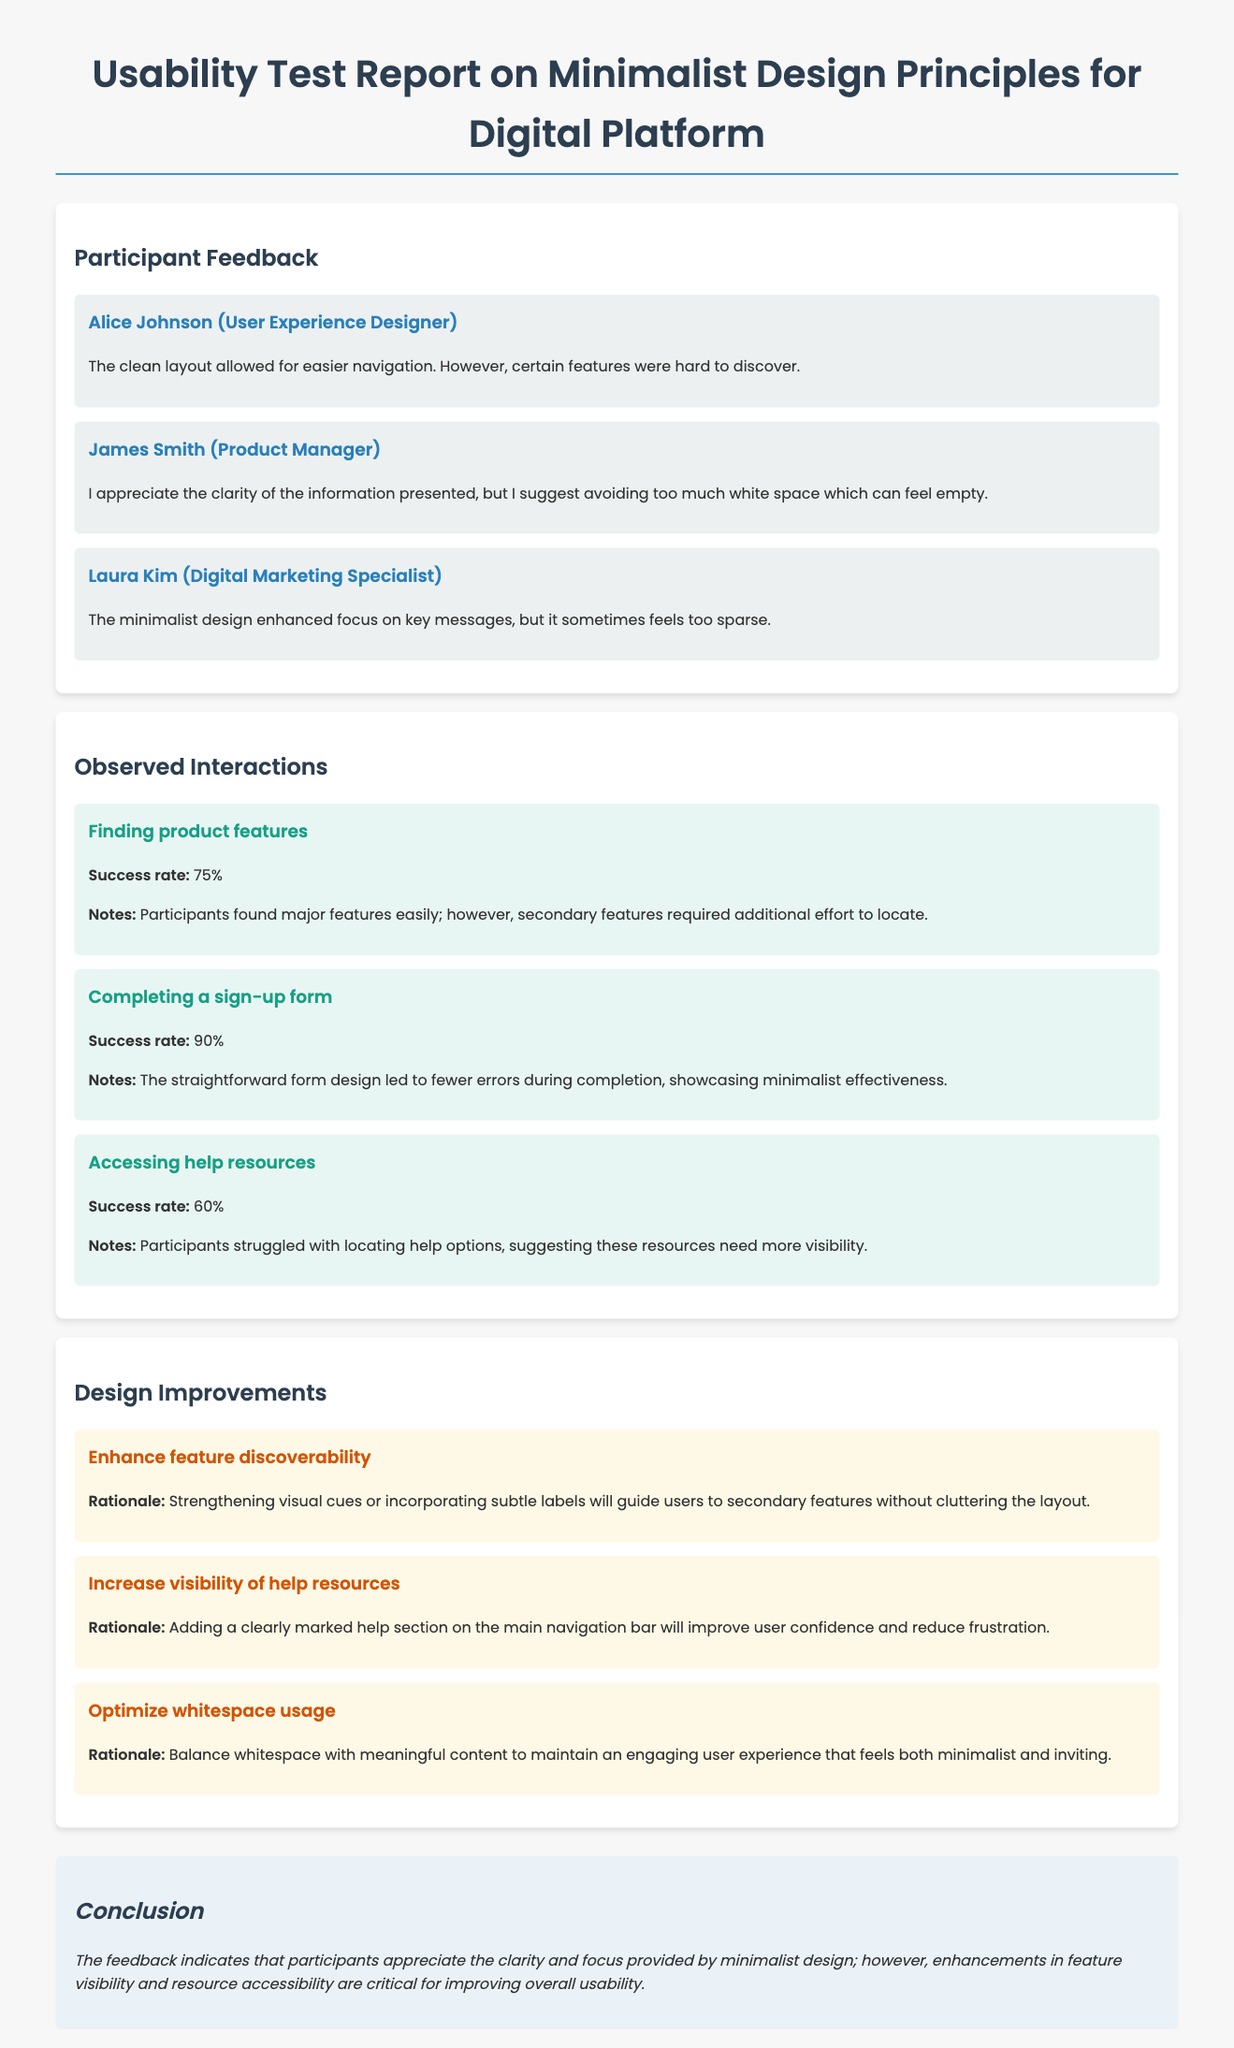What is the success rate for finding product features? The success rate for finding product features is noted in the Observed Interactions section of the document.
Answer: 75% Who suggested avoiding too much white space? The name associated with the feedback on avoiding too much white space is found in the Participant Feedback section.
Answer: James Smith How many tasks were observed in total? The total number of tasks can be calculated by counting each task described in the Observed Interactions section.
Answer: 3 What improvement is suggested for feature discoverability? The improvement for feature discoverability is mentioned in the Design Improvements section.
Answer: Enhance feature discoverability What percentage of participants successfully completed the sign-up form? This percentage is provided in the Observed Interactions section under the task for completing a sign-up form.
Answer: 90% Which participant felt the design was too sparse? This participant's feedback can be identified in the Participant Feedback section of the document.
Answer: Laura Kim What is the rationale for optimizing whitespace usage? The rationale for optimizing whitespace usage is provided in the Design Improvements section.
Answer: Balance whitespace with meaningful content What is one key takeaway from the conclusion? The key takeaway from the conclusion summarizes participant experiences and suggestions related to the design.
Answer: Enhancements in feature visibility and resource accessibility are critical 